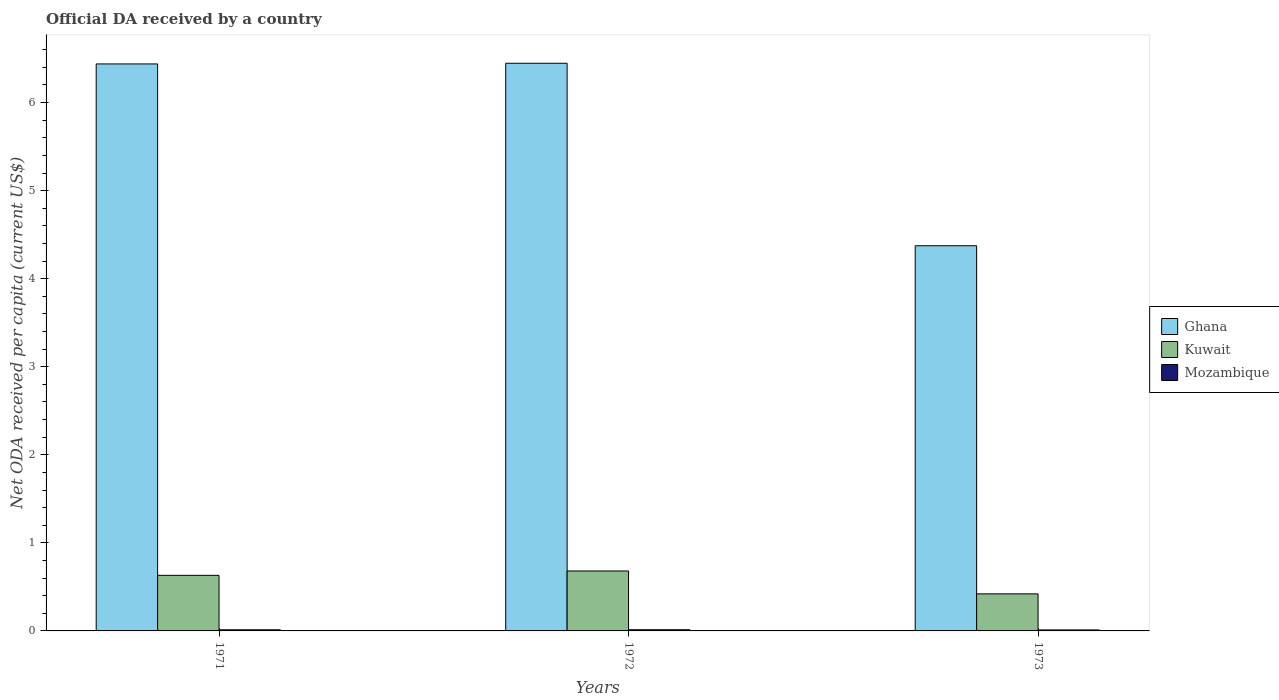How many different coloured bars are there?
Your answer should be very brief. 3. How many groups of bars are there?
Your answer should be compact. 3. Are the number of bars per tick equal to the number of legend labels?
Your response must be concise. Yes. How many bars are there on the 1st tick from the left?
Ensure brevity in your answer.  3. How many bars are there on the 2nd tick from the right?
Your answer should be compact. 3. What is the label of the 1st group of bars from the left?
Offer a very short reply. 1971. In how many cases, is the number of bars for a given year not equal to the number of legend labels?
Give a very brief answer. 0. What is the ODA received in in Ghana in 1971?
Provide a succinct answer. 6.44. Across all years, what is the maximum ODA received in in Kuwait?
Your answer should be compact. 0.68. Across all years, what is the minimum ODA received in in Mozambique?
Keep it short and to the point. 0.01. In which year was the ODA received in in Kuwait maximum?
Make the answer very short. 1972. In which year was the ODA received in in Mozambique minimum?
Your answer should be compact. 1973. What is the total ODA received in in Kuwait in the graph?
Keep it short and to the point. 1.73. What is the difference between the ODA received in in Ghana in 1972 and that in 1973?
Offer a terse response. 2.07. What is the difference between the ODA received in in Ghana in 1973 and the ODA received in in Kuwait in 1972?
Your response must be concise. 3.69. What is the average ODA received in in Ghana per year?
Keep it short and to the point. 5.75. In the year 1973, what is the difference between the ODA received in in Kuwait and ODA received in in Mozambique?
Ensure brevity in your answer.  0.41. What is the ratio of the ODA received in in Mozambique in 1972 to that in 1973?
Your answer should be compact. 1.21. Is the difference between the ODA received in in Kuwait in 1972 and 1973 greater than the difference between the ODA received in in Mozambique in 1972 and 1973?
Give a very brief answer. Yes. What is the difference between the highest and the second highest ODA received in in Kuwait?
Give a very brief answer. 0.05. What is the difference between the highest and the lowest ODA received in in Mozambique?
Ensure brevity in your answer.  0. In how many years, is the ODA received in in Mozambique greater than the average ODA received in in Mozambique taken over all years?
Offer a very short reply. 2. What does the 3rd bar from the left in 1971 represents?
Offer a very short reply. Mozambique. Is it the case that in every year, the sum of the ODA received in in Ghana and ODA received in in Mozambique is greater than the ODA received in in Kuwait?
Ensure brevity in your answer.  Yes. Are all the bars in the graph horizontal?
Keep it short and to the point. No. How many years are there in the graph?
Your answer should be very brief. 3. What is the difference between two consecutive major ticks on the Y-axis?
Your response must be concise. 1. Are the values on the major ticks of Y-axis written in scientific E-notation?
Make the answer very short. No. Does the graph contain any zero values?
Your answer should be compact. No. Does the graph contain grids?
Offer a terse response. No. Where does the legend appear in the graph?
Your response must be concise. Center right. How many legend labels are there?
Make the answer very short. 3. What is the title of the graph?
Your answer should be very brief. Official DA received by a country. What is the label or title of the X-axis?
Make the answer very short. Years. What is the label or title of the Y-axis?
Provide a succinct answer. Net ODA received per capita (current US$). What is the Net ODA received per capita (current US$) of Ghana in 1971?
Offer a very short reply. 6.44. What is the Net ODA received per capita (current US$) of Kuwait in 1971?
Your answer should be very brief. 0.63. What is the Net ODA received per capita (current US$) of Mozambique in 1971?
Provide a succinct answer. 0.01. What is the Net ODA received per capita (current US$) in Ghana in 1972?
Keep it short and to the point. 6.45. What is the Net ODA received per capita (current US$) in Kuwait in 1972?
Your answer should be compact. 0.68. What is the Net ODA received per capita (current US$) in Mozambique in 1972?
Provide a short and direct response. 0.01. What is the Net ODA received per capita (current US$) in Ghana in 1973?
Make the answer very short. 4.37. What is the Net ODA received per capita (current US$) of Kuwait in 1973?
Offer a very short reply. 0.42. What is the Net ODA received per capita (current US$) in Mozambique in 1973?
Ensure brevity in your answer.  0.01. Across all years, what is the maximum Net ODA received per capita (current US$) in Ghana?
Your response must be concise. 6.45. Across all years, what is the maximum Net ODA received per capita (current US$) of Kuwait?
Your response must be concise. 0.68. Across all years, what is the maximum Net ODA received per capita (current US$) in Mozambique?
Your answer should be very brief. 0.01. Across all years, what is the minimum Net ODA received per capita (current US$) of Ghana?
Provide a short and direct response. 4.37. Across all years, what is the minimum Net ODA received per capita (current US$) of Kuwait?
Your answer should be compact. 0.42. Across all years, what is the minimum Net ODA received per capita (current US$) of Mozambique?
Your response must be concise. 0.01. What is the total Net ODA received per capita (current US$) in Ghana in the graph?
Ensure brevity in your answer.  17.26. What is the total Net ODA received per capita (current US$) in Kuwait in the graph?
Provide a succinct answer. 1.73. What is the total Net ODA received per capita (current US$) of Mozambique in the graph?
Your answer should be very brief. 0.04. What is the difference between the Net ODA received per capita (current US$) of Ghana in 1971 and that in 1972?
Provide a short and direct response. -0.01. What is the difference between the Net ODA received per capita (current US$) of Kuwait in 1971 and that in 1972?
Your answer should be compact. -0.05. What is the difference between the Net ODA received per capita (current US$) of Mozambique in 1971 and that in 1972?
Provide a short and direct response. -0. What is the difference between the Net ODA received per capita (current US$) in Ghana in 1971 and that in 1973?
Give a very brief answer. 2.06. What is the difference between the Net ODA received per capita (current US$) of Kuwait in 1971 and that in 1973?
Give a very brief answer. 0.21. What is the difference between the Net ODA received per capita (current US$) in Mozambique in 1971 and that in 1973?
Provide a succinct answer. 0. What is the difference between the Net ODA received per capita (current US$) of Ghana in 1972 and that in 1973?
Provide a short and direct response. 2.07. What is the difference between the Net ODA received per capita (current US$) of Kuwait in 1972 and that in 1973?
Make the answer very short. 0.26. What is the difference between the Net ODA received per capita (current US$) in Mozambique in 1972 and that in 1973?
Your answer should be very brief. 0. What is the difference between the Net ODA received per capita (current US$) in Ghana in 1971 and the Net ODA received per capita (current US$) in Kuwait in 1972?
Your answer should be compact. 5.76. What is the difference between the Net ODA received per capita (current US$) in Ghana in 1971 and the Net ODA received per capita (current US$) in Mozambique in 1972?
Offer a very short reply. 6.43. What is the difference between the Net ODA received per capita (current US$) in Kuwait in 1971 and the Net ODA received per capita (current US$) in Mozambique in 1972?
Provide a succinct answer. 0.62. What is the difference between the Net ODA received per capita (current US$) of Ghana in 1971 and the Net ODA received per capita (current US$) of Kuwait in 1973?
Ensure brevity in your answer.  6.02. What is the difference between the Net ODA received per capita (current US$) in Ghana in 1971 and the Net ODA received per capita (current US$) in Mozambique in 1973?
Give a very brief answer. 6.43. What is the difference between the Net ODA received per capita (current US$) in Kuwait in 1971 and the Net ODA received per capita (current US$) in Mozambique in 1973?
Provide a succinct answer. 0.62. What is the difference between the Net ODA received per capita (current US$) in Ghana in 1972 and the Net ODA received per capita (current US$) in Kuwait in 1973?
Your response must be concise. 6.03. What is the difference between the Net ODA received per capita (current US$) in Ghana in 1972 and the Net ODA received per capita (current US$) in Mozambique in 1973?
Keep it short and to the point. 6.44. What is the difference between the Net ODA received per capita (current US$) of Kuwait in 1972 and the Net ODA received per capita (current US$) of Mozambique in 1973?
Make the answer very short. 0.67. What is the average Net ODA received per capita (current US$) in Ghana per year?
Your response must be concise. 5.75. What is the average Net ODA received per capita (current US$) in Kuwait per year?
Provide a short and direct response. 0.58. What is the average Net ODA received per capita (current US$) in Mozambique per year?
Your response must be concise. 0.01. In the year 1971, what is the difference between the Net ODA received per capita (current US$) of Ghana and Net ODA received per capita (current US$) of Kuwait?
Your answer should be very brief. 5.81. In the year 1971, what is the difference between the Net ODA received per capita (current US$) in Ghana and Net ODA received per capita (current US$) in Mozambique?
Keep it short and to the point. 6.43. In the year 1971, what is the difference between the Net ODA received per capita (current US$) of Kuwait and Net ODA received per capita (current US$) of Mozambique?
Ensure brevity in your answer.  0.62. In the year 1972, what is the difference between the Net ODA received per capita (current US$) of Ghana and Net ODA received per capita (current US$) of Kuwait?
Ensure brevity in your answer.  5.77. In the year 1972, what is the difference between the Net ODA received per capita (current US$) in Ghana and Net ODA received per capita (current US$) in Mozambique?
Offer a very short reply. 6.43. In the year 1972, what is the difference between the Net ODA received per capita (current US$) of Kuwait and Net ODA received per capita (current US$) of Mozambique?
Your answer should be very brief. 0.67. In the year 1973, what is the difference between the Net ODA received per capita (current US$) in Ghana and Net ODA received per capita (current US$) in Kuwait?
Keep it short and to the point. 3.95. In the year 1973, what is the difference between the Net ODA received per capita (current US$) in Ghana and Net ODA received per capita (current US$) in Mozambique?
Offer a very short reply. 4.36. In the year 1973, what is the difference between the Net ODA received per capita (current US$) in Kuwait and Net ODA received per capita (current US$) in Mozambique?
Your answer should be very brief. 0.41. What is the ratio of the Net ODA received per capita (current US$) in Kuwait in 1971 to that in 1972?
Offer a terse response. 0.93. What is the ratio of the Net ODA received per capita (current US$) of Mozambique in 1971 to that in 1972?
Your answer should be very brief. 0.94. What is the ratio of the Net ODA received per capita (current US$) in Ghana in 1971 to that in 1973?
Make the answer very short. 1.47. What is the ratio of the Net ODA received per capita (current US$) in Kuwait in 1971 to that in 1973?
Offer a terse response. 1.5. What is the ratio of the Net ODA received per capita (current US$) in Mozambique in 1971 to that in 1973?
Offer a very short reply. 1.14. What is the ratio of the Net ODA received per capita (current US$) of Ghana in 1972 to that in 1973?
Offer a very short reply. 1.47. What is the ratio of the Net ODA received per capita (current US$) of Kuwait in 1972 to that in 1973?
Ensure brevity in your answer.  1.62. What is the ratio of the Net ODA received per capita (current US$) in Mozambique in 1972 to that in 1973?
Give a very brief answer. 1.21. What is the difference between the highest and the second highest Net ODA received per capita (current US$) in Ghana?
Your answer should be very brief. 0.01. What is the difference between the highest and the second highest Net ODA received per capita (current US$) of Kuwait?
Your response must be concise. 0.05. What is the difference between the highest and the second highest Net ODA received per capita (current US$) of Mozambique?
Provide a succinct answer. 0. What is the difference between the highest and the lowest Net ODA received per capita (current US$) in Ghana?
Make the answer very short. 2.07. What is the difference between the highest and the lowest Net ODA received per capita (current US$) of Kuwait?
Ensure brevity in your answer.  0.26. What is the difference between the highest and the lowest Net ODA received per capita (current US$) in Mozambique?
Your answer should be very brief. 0. 